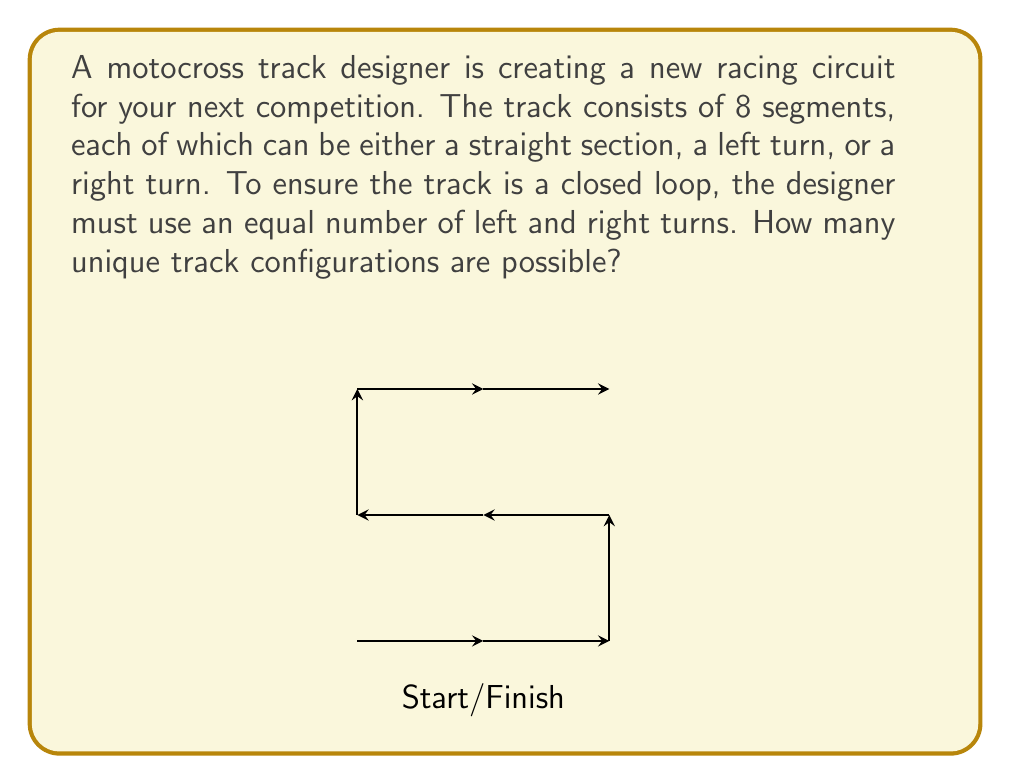What is the answer to this math problem? Let's approach this step-by-step:

1) We know that the track has 8 segments in total, and the number of left turns must equal the number of right turns.

2) Let $x$ be the number of left turns (which is also the number of right turns). Then the number of straight sections is $8 - 2x$.

3) The possible values for $x$ are 0, 1, 2, 3, or 4. We need to consider each case:

   Case 1 ($x = 0$): All 8 segments are straight. There's only 1 way to do this.
   
   Case 2 ($x = 1$): 1 left turn, 1 right turn, 6 straights. We need to choose positions for these turns.
   
   Case 3 ($x = 2$): 2 left turns, 2 right turns, 4 straights.
   
   Case 4 ($x = 3$): 3 left turns, 3 right turns, 2 straights.
   
   Case 5 ($x = 4$): 4 left turns, 4 right turns, no straights.

4) For each case (except Case 1), we need to calculate the number of ways to arrange the turns.

5) This is a combination problem. For Case 2, we're choosing 2 positions out of 8 for the turns: $\binom{8}{2}$

6) For Case 3, we're choosing 4 positions out of 8 for the turns, then choosing which 2 of those 4 are left turns: $\binom{8}{4} \cdot \binom{4}{2}$

7) Case 4 is similar to Case 3: $\binom{8}{6} \cdot \binom{6}{3}$

8) For Case 5, we're just choosing which 4 of the 8 positions are left turns: $\binom{8}{4}$

9) The total number of configurations is the sum of all these cases:

   $$1 + \binom{8}{2} + \binom{8}{4} \cdot \binom{4}{2} + \binom{8}{6} \cdot \binom{6}{3} + \binom{8}{4}$$

10) Calculating:
    $$1 + 28 + 70 \cdot 6 + 28 \cdot 20 + 70 = 1 + 28 + 420 + 560 + 70 = 1079$$
Answer: 1079 